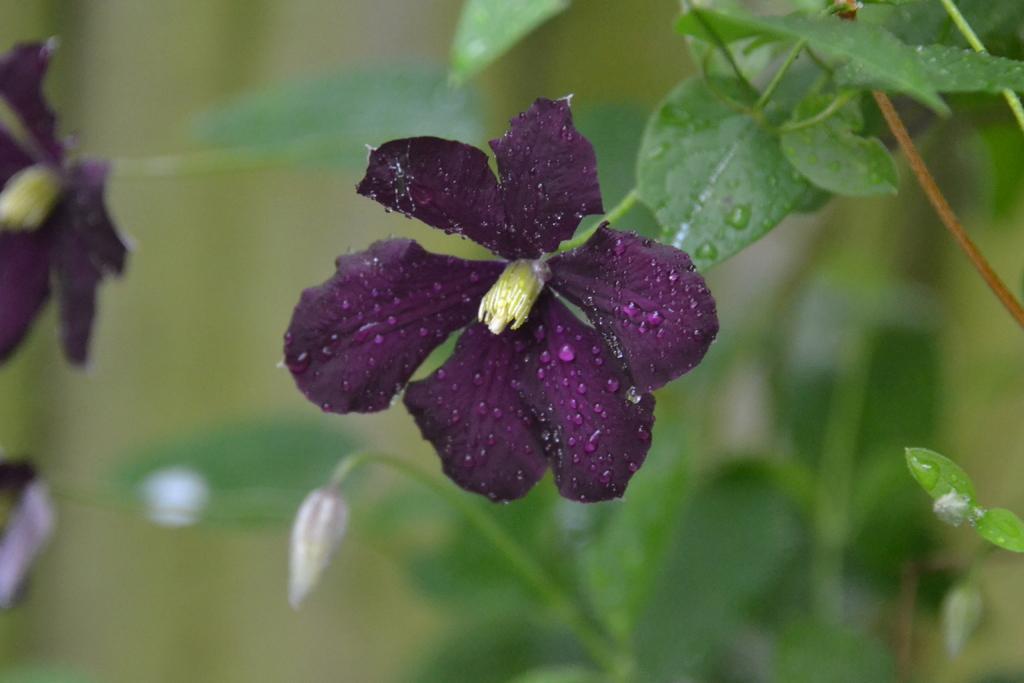Can you describe this image briefly? In this image I can see a flower which is pink in color to a plant which is green in color. I can see the blurry background in which I can see few flowers and plants. 